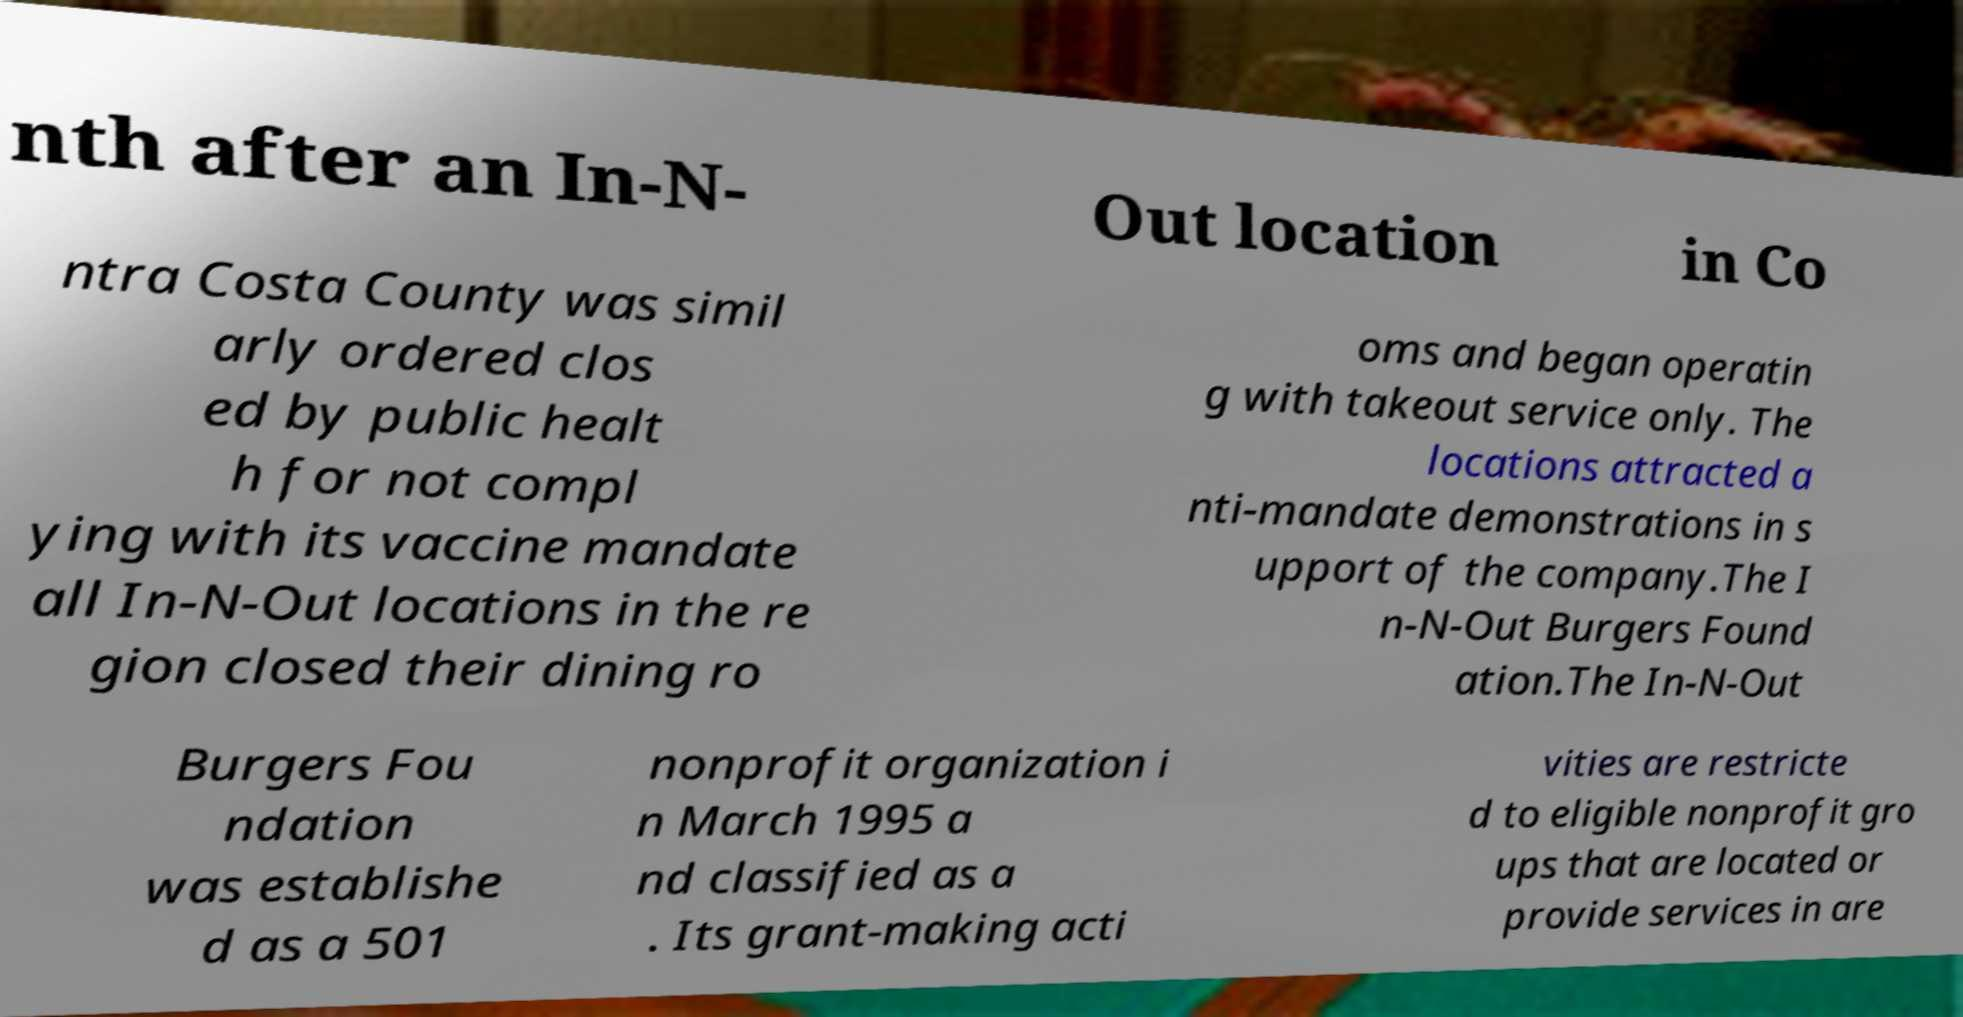I need the written content from this picture converted into text. Can you do that? nth after an In-N- Out location in Co ntra Costa County was simil arly ordered clos ed by public healt h for not compl ying with its vaccine mandate all In-N-Out locations in the re gion closed their dining ro oms and began operatin g with takeout service only. The locations attracted a nti-mandate demonstrations in s upport of the company.The I n-N-Out Burgers Found ation.The In-N-Out Burgers Fou ndation was establishe d as a 501 nonprofit organization i n March 1995 a nd classified as a . Its grant-making acti vities are restricte d to eligible nonprofit gro ups that are located or provide services in are 